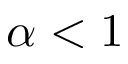Convert formula to latex. <formula><loc_0><loc_0><loc_500><loc_500>\alpha < 1</formula> 